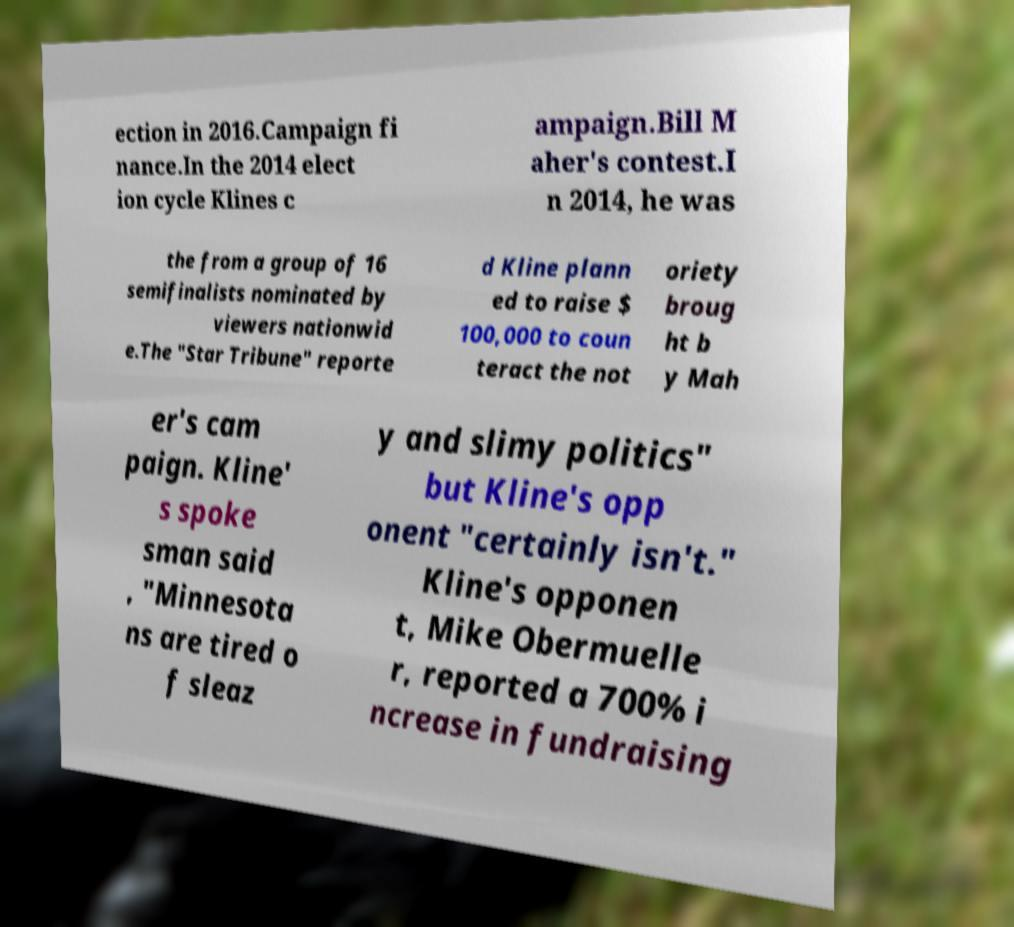For documentation purposes, I need the text within this image transcribed. Could you provide that? ection in 2016.Campaign fi nance.In the 2014 elect ion cycle Klines c ampaign.Bill M aher's contest.I n 2014, he was the from a group of 16 semifinalists nominated by viewers nationwid e.The "Star Tribune" reporte d Kline plann ed to raise $ 100,000 to coun teract the not oriety broug ht b y Mah er's cam paign. Kline' s spoke sman said , "Minnesota ns are tired o f sleaz y and slimy politics" but Kline's opp onent "certainly isn't." Kline's opponen t, Mike Obermuelle r, reported a 700% i ncrease in fundraising 